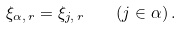Convert formula to latex. <formula><loc_0><loc_0><loc_500><loc_500>\xi _ { \alpha , \, r } = \xi _ { j , \, r } \quad ( j \in \alpha ) \, .</formula> 